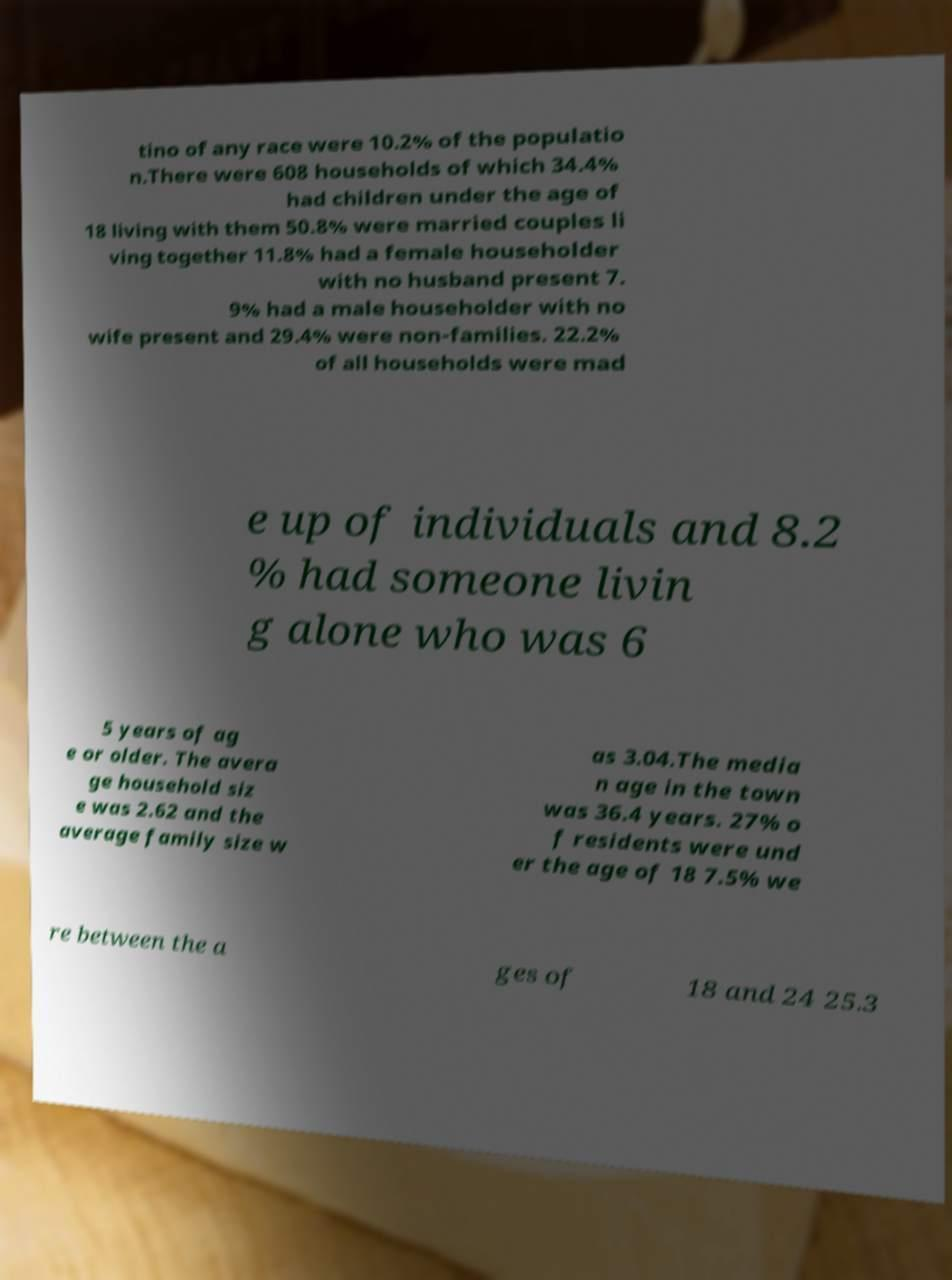There's text embedded in this image that I need extracted. Can you transcribe it verbatim? tino of any race were 10.2% of the populatio n.There were 608 households of which 34.4% had children under the age of 18 living with them 50.8% were married couples li ving together 11.8% had a female householder with no husband present 7. 9% had a male householder with no wife present and 29.4% were non-families. 22.2% of all households were mad e up of individuals and 8.2 % had someone livin g alone who was 6 5 years of ag e or older. The avera ge household siz e was 2.62 and the average family size w as 3.04.The media n age in the town was 36.4 years. 27% o f residents were und er the age of 18 7.5% we re between the a ges of 18 and 24 25.3 